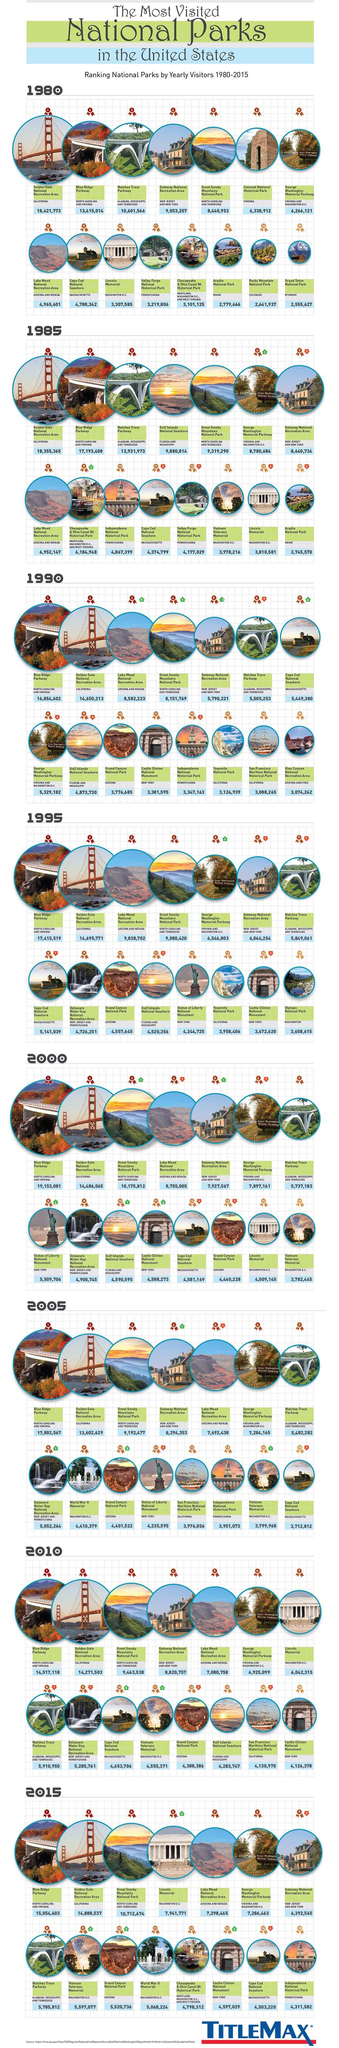Draw attention to some important aspects in this diagram. In 2005, Grand Canyon National Park received the highest ranking among the years 2000, 2005, and 2010. In 1990, the ranking of Lake Mead National Recreation Area improved by 5 positions. There are 15 national parks listed. The number of visitors to Gateway National Recreation Area increased from 1990 to 1995, from 2,74,033 to 3,10,285, representing a significant increase of 1,36,252 visitors over the five-year period. In 1990, Golden Gate National Park saw the highest number of visitors compared to the years of 1980 and 1985. 